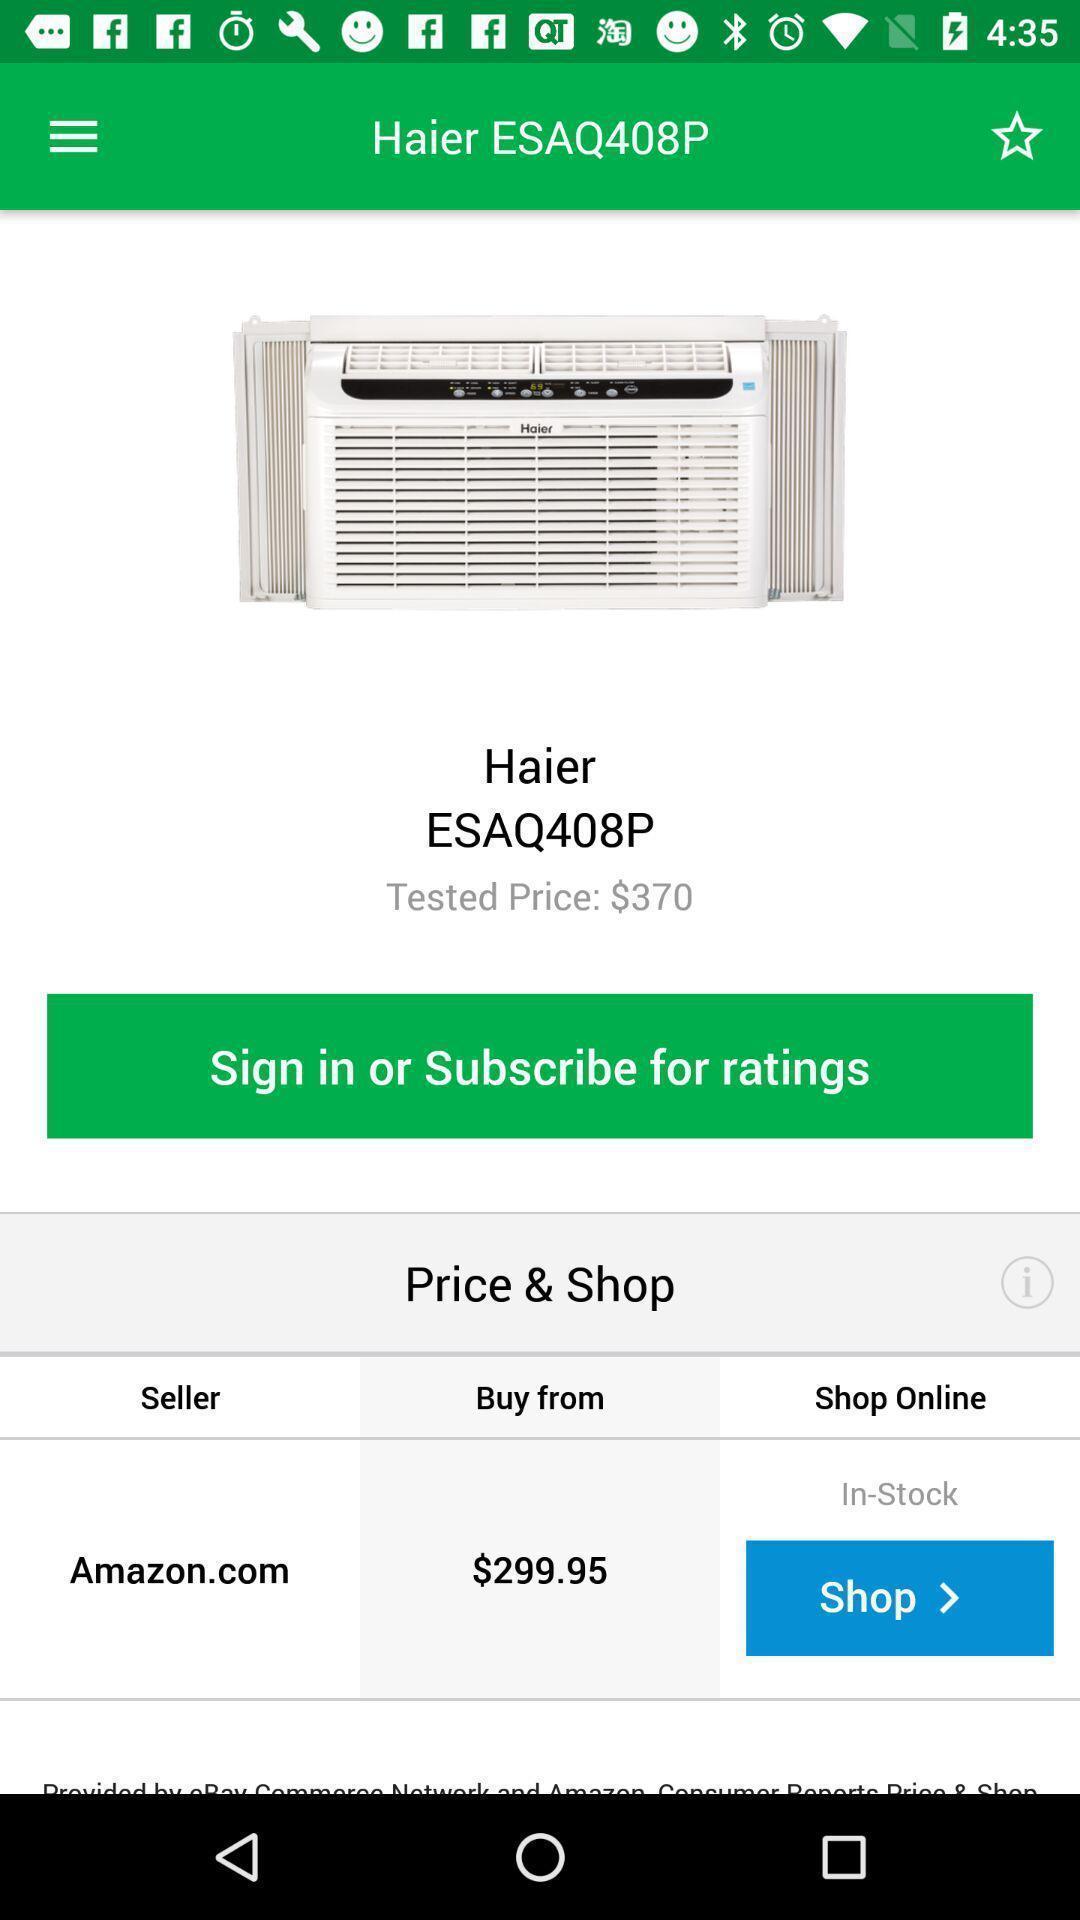Give me a narrative description of this picture. Screen displays product information in shopping app. 